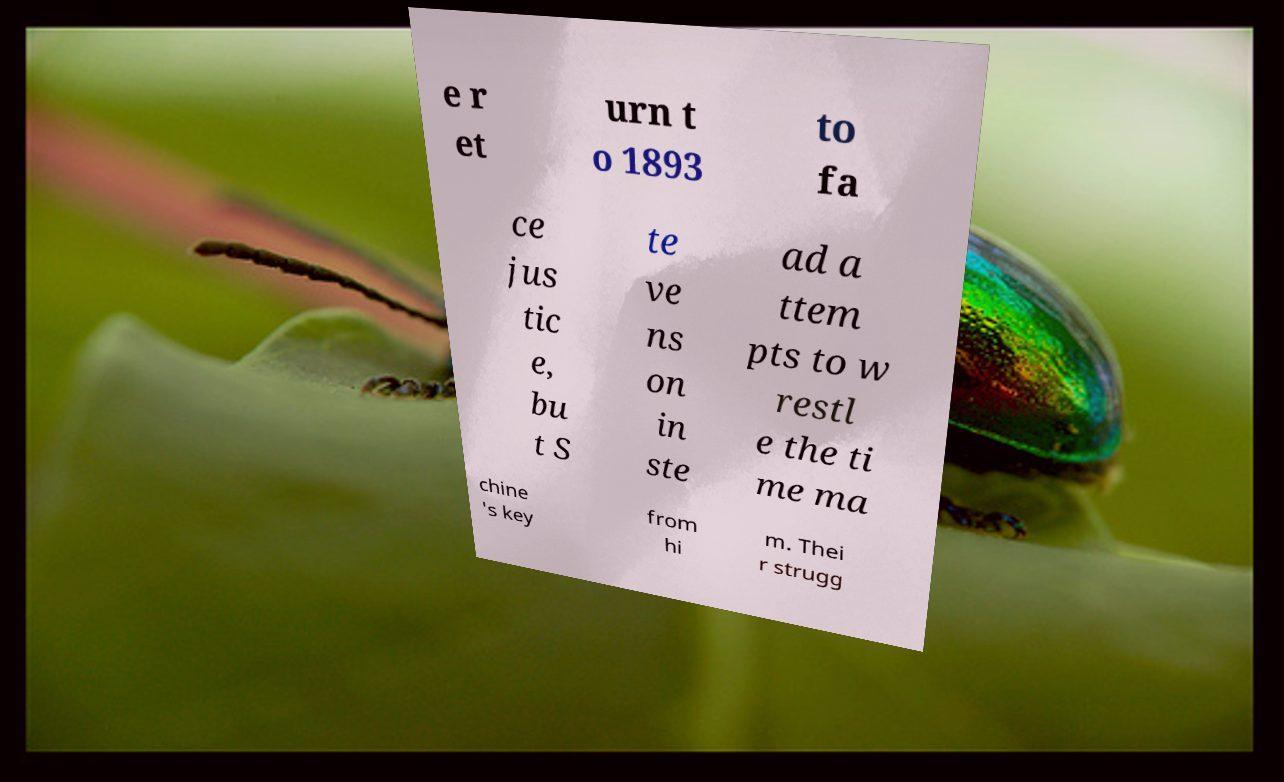Can you read and provide the text displayed in the image?This photo seems to have some interesting text. Can you extract and type it out for me? e r et urn t o 1893 to fa ce jus tic e, bu t S te ve ns on in ste ad a ttem pts to w restl e the ti me ma chine 's key from hi m. Thei r strugg 